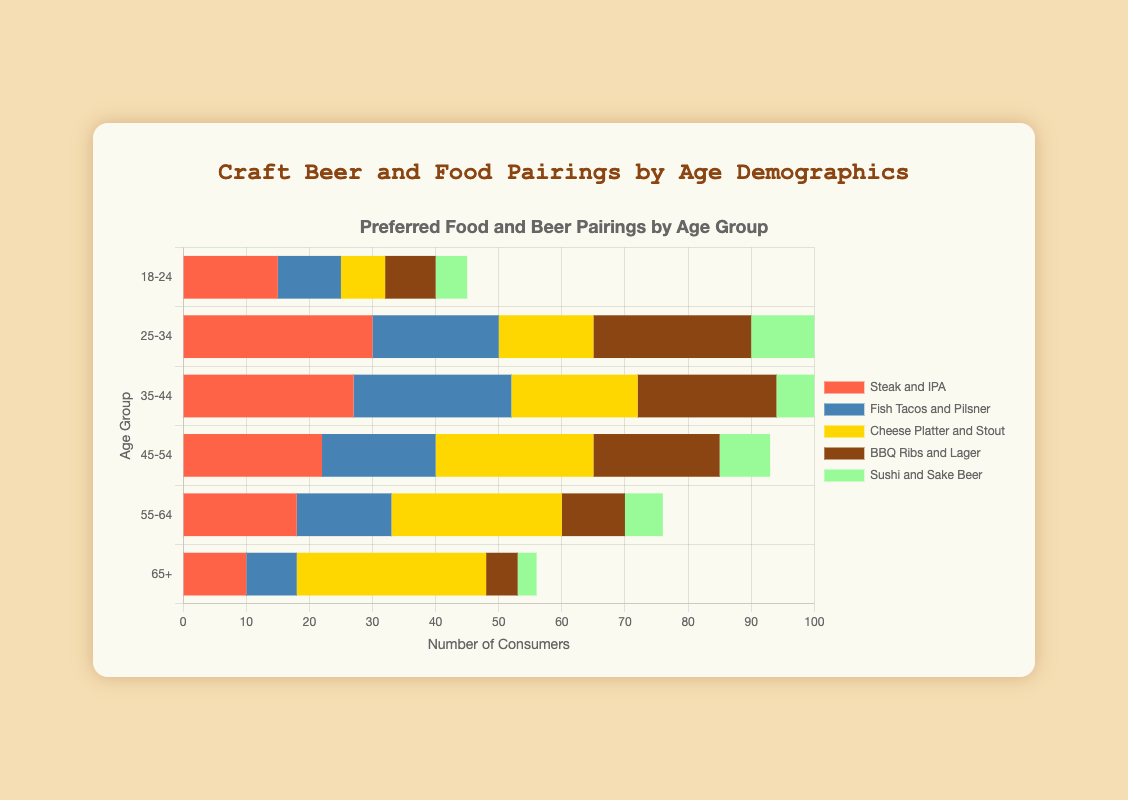What's the most popular food and beer pairing for the 25-34 age group? To find the most popular food and beer pairing for the 25-34 age group, look at the data values for each food pairing in this age group and identify the highest number. The pairings and their values are: Steak and IPA (30), Fish Tacos and Pilsner (20), Cheese Platter and Stout (15), BBQ Ribs and Lager (25), Sushi and Sake Beer (12). Steak and IPA has the highest value of 30.
Answer: Steak and IPA Which age group has the highest preference for Cheese Platter and Stout? To find which age group prefers Cheese Platter and Stout the most, compare the values for Cheese Platter and Stout across all age groups. The values are: 18-24 (7), 25-34 (15), 35-44 (20), 45-54 (25), 55-64 (27), 65+ (30). The age group 65+ has the highest value of 30.
Answer: 65+ Which pairing is more popular for the 35-44 age group: Fish Tacos and Pilsner or BBQ Ribs and Lager? To determine the more popular pairing, compare the values for Fish Tacos and Pilsner and BBQ Ribs and Lager in the 35-44 age group. Fish Tacos and Pilsner has a value of 25, while BBQ Ribs and Lager has a value of 22. Therefore, Fish Tacos and Pilsner is more popular.
Answer: Fish Tacos and Pilsner Summing up all the consumers who prefer Cheese Platter and Stout, what is the total number? Add up the number of consumers for Cheese Platter and Stout across all age groups: 7 (18-24) + 15 (25-34) + 20 (35-44) + 25 (45-54) + 27 (55-64) + 30 (65+) = 124.
Answer: 124 What is the average number of consumers preferring BBQ Ribs and Lager across all age groups? Calculate the average by summing the number of consumers for BBQ Ribs and Lager across all age groups and then dividing by the number of age groups. The values are: 8 (18-24), 25 (25-34), 22 (35-44), 20 (45-54), 10 (55-64), 5 (65+).
Sum = 8 + 25 + 22 + 20 + 10 + 5 = 90. There are 6 age groups, so the average is 90 / 6 = 15.
Answer: 15 Which age group has the lowest preference for Sushi and Sake Beer? To determine the age group with the lowest preference for Sushi and Sake Beer, compare the values for this pairing across all age groups. The values are: 18-24 (5), 25-34 (12), 35-44 (10), 45-54 (8), 55-64 (6), 65+ (3). The age group 65+ has the lowest value of 3.
Answer: 65+ Which food and beer pairing shows a consistently increasing preference with age? To identify the pairing with a consistently increasing preference, look at the values for each pairing from the youngest to the oldest age group. The values for Cheese Platter and Stout are: 7 (18-24), 15 (25-34), 20 (35-44), 25 (45-54), 27 (55-64), 30 (65+). These values show a consistent increase.
Answer: Cheese Platter and Stout Calculate the difference in the number of consumers preferring Steak and IPA between the 25-34 and 18-24 age groups. To find the difference, subtract the number of consumers in the 18-24 age group from the number in the 25-34 age group for Steak and IPA. The values are: 30 (25-34) and 15 (18-24). Difference = 30 - 15 = 15.
Answer: 15 What's the sum of consumers for Fish Tacos and Pilsner for age groups under 45? Add the number of consumers for Fish Tacos and Pilsner for the age groups 18-24, 25-34, and 35-44. The values are: 10 (18-24) + 20 (25-34) + 25 (35-44). Sum = 10 + 20 + 25 = 55.
Answer: 55 